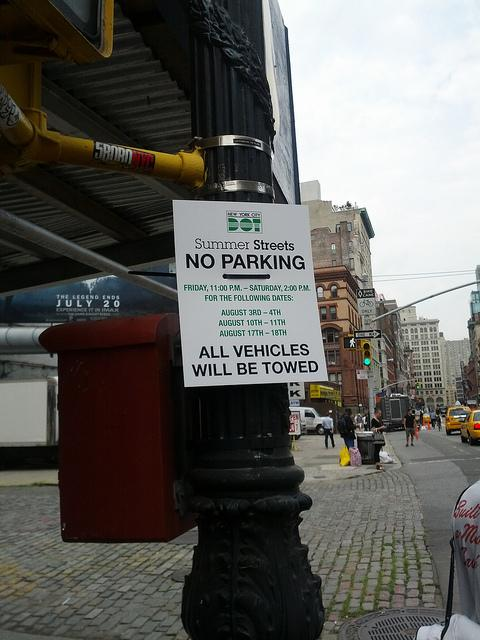What is the green on the bricks on the ground? Please explain your reasoning. moss. It is like a grassy growth that usually occurs widespread on objects like bricks. 